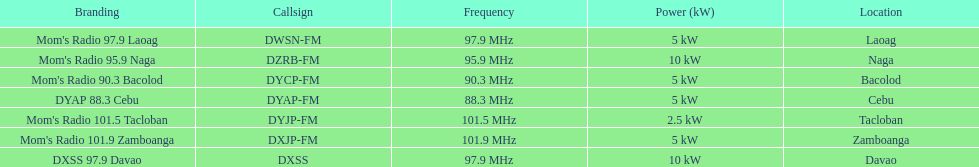How many stations show 5 kw or above in the power column? 6. 